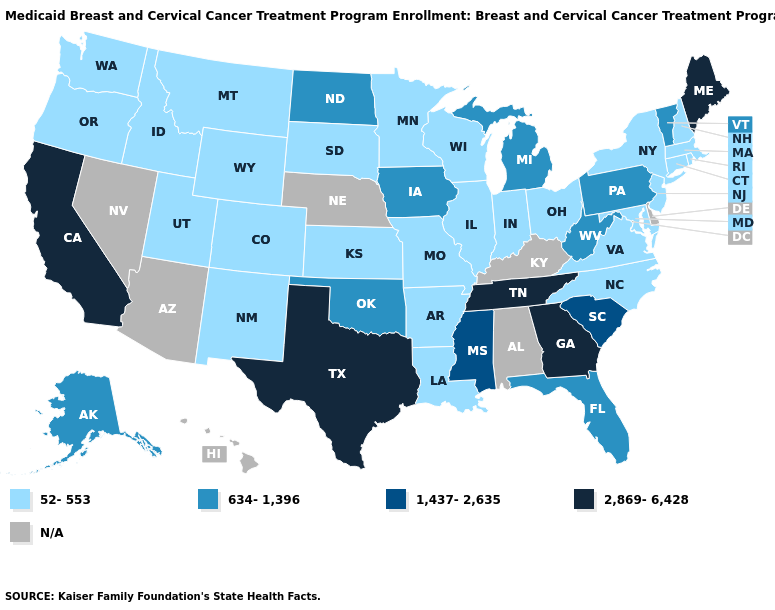Name the states that have a value in the range N/A?
Answer briefly. Alabama, Arizona, Delaware, Hawaii, Kentucky, Nebraska, Nevada. Name the states that have a value in the range 1,437-2,635?
Answer briefly. Mississippi, South Carolina. Name the states that have a value in the range 634-1,396?
Answer briefly. Alaska, Florida, Iowa, Michigan, North Dakota, Oklahoma, Pennsylvania, Vermont, West Virginia. Which states have the highest value in the USA?
Be succinct. California, Georgia, Maine, Tennessee, Texas. What is the value of Hawaii?
Quick response, please. N/A. Name the states that have a value in the range 1,437-2,635?
Give a very brief answer. Mississippi, South Carolina. What is the value of California?
Be succinct. 2,869-6,428. What is the value of Pennsylvania?
Concise answer only. 634-1,396. What is the highest value in the USA?
Keep it brief. 2,869-6,428. What is the lowest value in the South?
Be succinct. 52-553. Does the first symbol in the legend represent the smallest category?
Give a very brief answer. Yes. Name the states that have a value in the range 52-553?
Concise answer only. Arkansas, Colorado, Connecticut, Idaho, Illinois, Indiana, Kansas, Louisiana, Maryland, Massachusetts, Minnesota, Missouri, Montana, New Hampshire, New Jersey, New Mexico, New York, North Carolina, Ohio, Oregon, Rhode Island, South Dakota, Utah, Virginia, Washington, Wisconsin, Wyoming. Which states have the lowest value in the USA?
Be succinct. Arkansas, Colorado, Connecticut, Idaho, Illinois, Indiana, Kansas, Louisiana, Maryland, Massachusetts, Minnesota, Missouri, Montana, New Hampshire, New Jersey, New Mexico, New York, North Carolina, Ohio, Oregon, Rhode Island, South Dakota, Utah, Virginia, Washington, Wisconsin, Wyoming. Which states hav the highest value in the West?
Be succinct. California. Is the legend a continuous bar?
Concise answer only. No. 